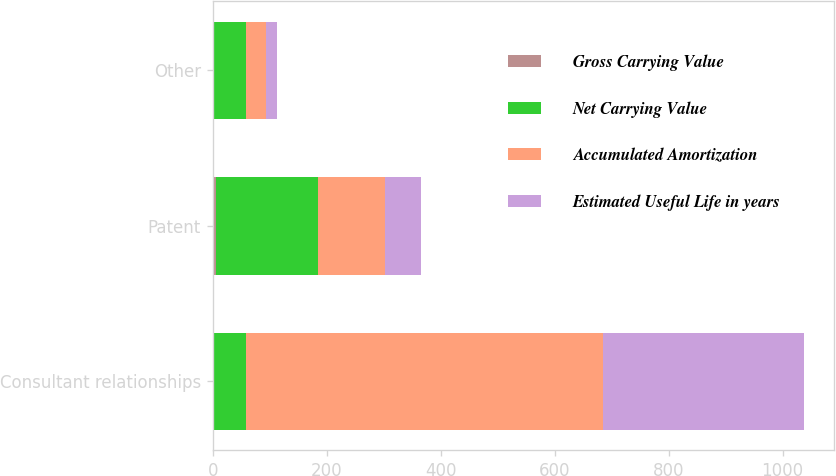<chart> <loc_0><loc_0><loc_500><loc_500><stacked_bar_chart><ecel><fcel>Consultant relationships<fcel>Patent<fcel>Other<nl><fcel>Gross Carrying Value<fcel>3<fcel>5<fcel>3<nl><fcel>Net Carrying Value<fcel>55<fcel>180<fcel>55<nl><fcel>Accumulated Amortization<fcel>626<fcel>117<fcel>36<nl><fcel>Estimated Useful Life in years<fcel>354<fcel>63<fcel>19<nl></chart> 